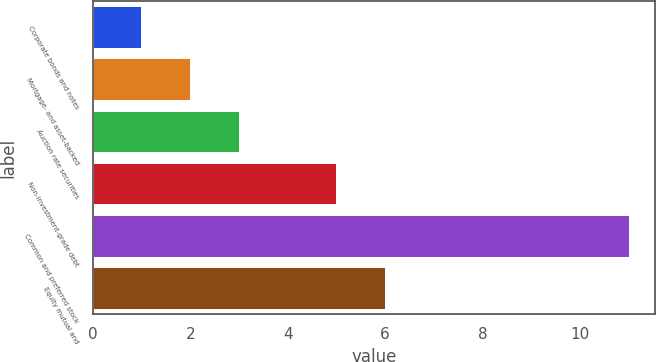Convert chart. <chart><loc_0><loc_0><loc_500><loc_500><bar_chart><fcel>Corporate bonds and notes<fcel>Mortgage- and asset-backed<fcel>Auction rate securities<fcel>Non-investment-grade debt<fcel>Common and preferred stock<fcel>Equity mutual and<nl><fcel>1<fcel>2<fcel>3<fcel>5<fcel>11<fcel>6<nl></chart> 